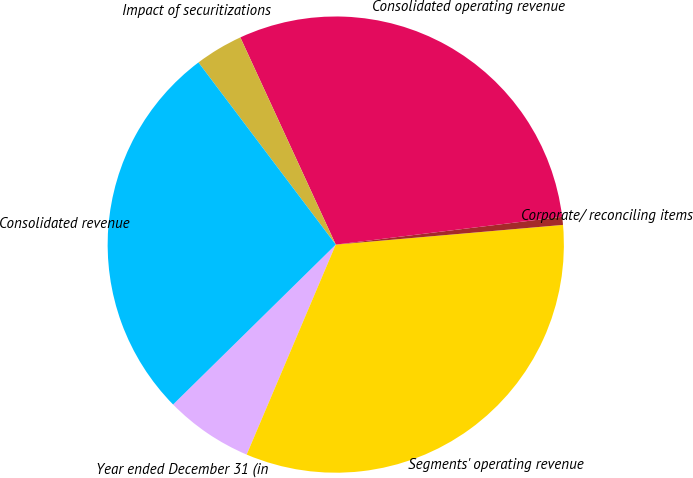Convert chart to OTSL. <chart><loc_0><loc_0><loc_500><loc_500><pie_chart><fcel>Year ended December 31 (in<fcel>Segments' operating revenue<fcel>Corporate/ reconciling items<fcel>Consolidated operating revenue<fcel>Impact of securitizations<fcel>Consolidated revenue<nl><fcel>6.25%<fcel>32.76%<fcel>0.57%<fcel>29.92%<fcel>3.41%<fcel>27.08%<nl></chart> 